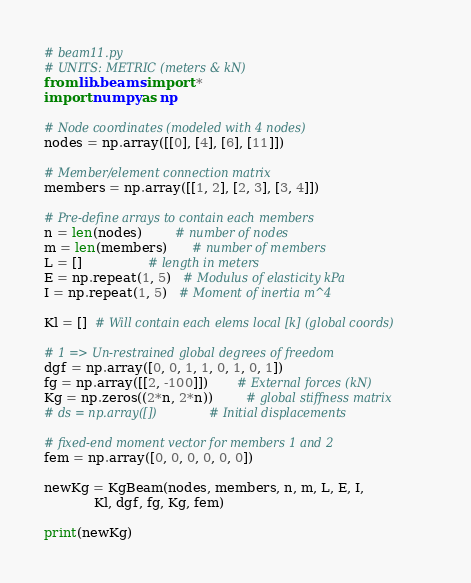<code> <loc_0><loc_0><loc_500><loc_500><_Python_># beam11.py
# UNITS: METRIC (meters & kN)
from lib.beams import *
import numpy as np

# Node coordinates (modeled with 4 nodes)
nodes = np.array([[0], [4], [6], [11]])

# Member/element connection matrix
members = np.array([[1, 2], [2, 3], [3, 4]])

# Pre-define arrays to contain each members
n = len(nodes)        # number of nodes
m = len(members)      # number of members
L = []                # length in meters
E = np.repeat(1, 5)   # Modulus of elasticity kPa
I = np.repeat(1, 5)   # Moment of inertia m^4

Kl = []  # Will contain each elems local [k] (global coords)

# 1 => Un-restrained global degrees of freedom
dgf = np.array([0, 0, 1, 1, 0, 1, 0, 1])
fg = np.array([[2, -100]])       # External forces (kN)
Kg = np.zeros((2*n, 2*n))        # global stiffness matrix
# ds = np.array([])              # Initial displacements

# fixed-end moment vector for members 1 and 2
fem = np.array([0, 0, 0, 0, 0, 0])

newKg = KgBeam(nodes, members, n, m, L, E, I,
            Kl, dgf, fg, Kg, fem)

print(newKg)
</code> 